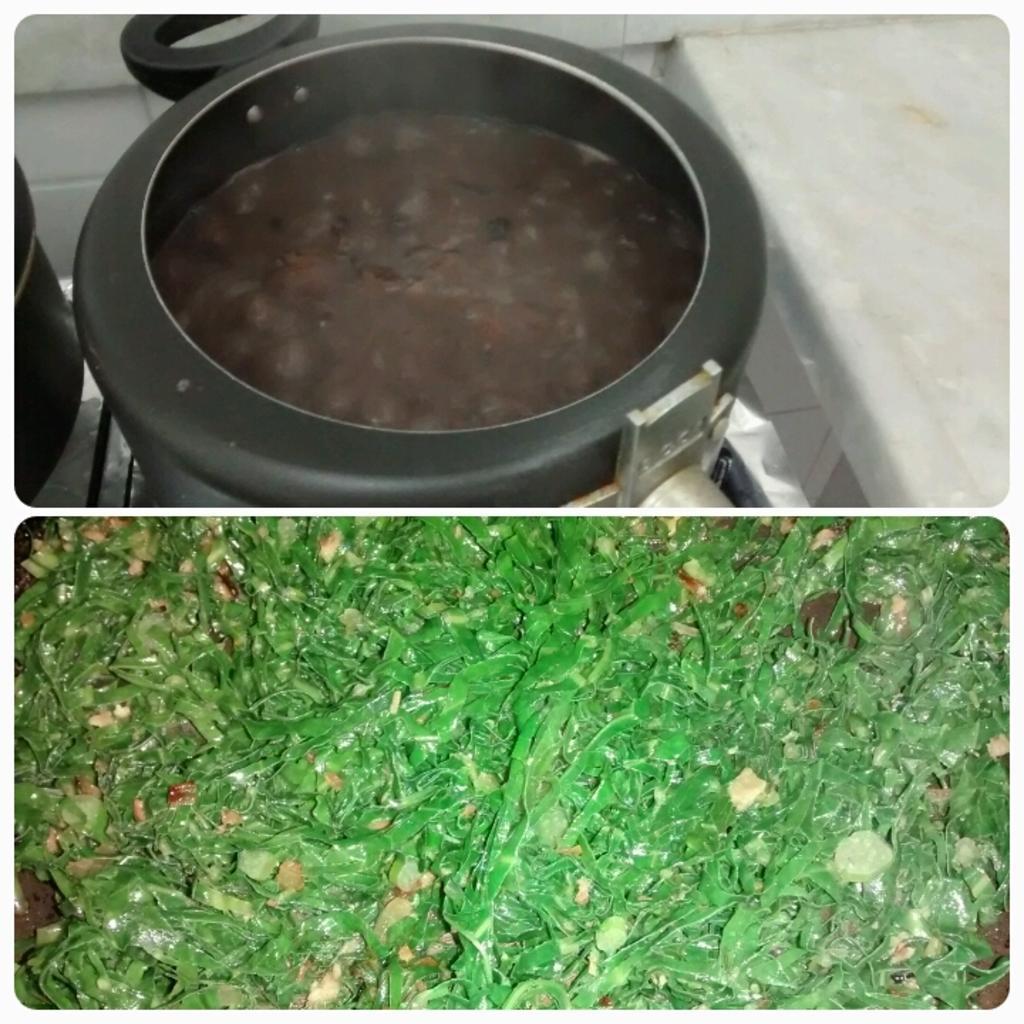Describe this image in one or two sentences. This is a collage image where, in the top image I can see a cooker in which some food item is cooking and it is placed on the stove. In the bottom image I can see something which is in green color. 